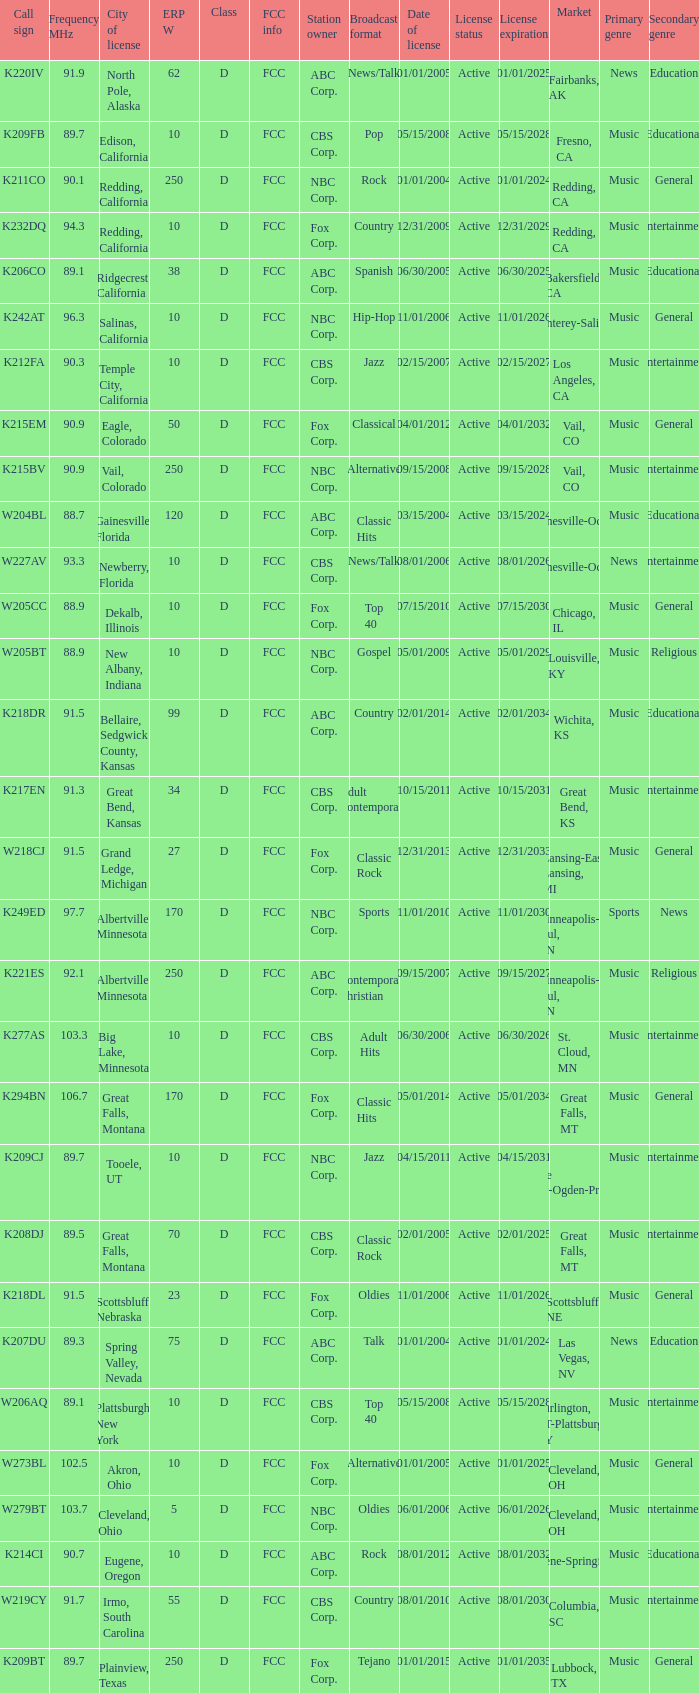Could you help me parse every detail presented in this table? {'header': ['Call sign', 'Frequency MHz', 'City of license', 'ERP W', 'Class', 'FCC info', 'Station owner', 'Broadcast format', 'Date of license', 'License status', 'License expiration', 'Market', 'Primary genre', 'Secondary genre'], 'rows': [['K220IV', '91.9', 'North Pole, Alaska', '62', 'D', 'FCC', 'ABC Corp.', 'News/Talk', '01/01/2005', 'Active', '01/01/2025', 'Fairbanks, AK', 'News', 'Education'], ['K209FB', '89.7', 'Edison, California', '10', 'D', 'FCC', 'CBS Corp.', 'Pop', '05/15/2008', 'Active', '05/15/2028', 'Fresno, CA', 'Music', 'Educational'], ['K211CO', '90.1', 'Redding, California', '250', 'D', 'FCC', 'NBC Corp.', 'Rock', '01/01/2004', 'Active', '01/01/2024', 'Redding, CA', 'Music', 'General'], ['K232DQ', '94.3', 'Redding, California', '10', 'D', 'FCC', 'Fox Corp.', 'Country', '12/31/2009', 'Active', '12/31/2029', 'Redding, CA', 'Music', 'Entertainment'], ['K206CO', '89.1', 'Ridgecrest, California', '38', 'D', 'FCC', 'ABC Corp.', 'Spanish', '06/30/2005', 'Active', '06/30/2025', 'Bakersfield, CA', 'Music', 'Educational'], ['K242AT', '96.3', 'Salinas, California', '10', 'D', 'FCC', 'NBC Corp.', 'Hip-Hop', '11/01/2006', 'Active', '11/01/2026', 'Monterey-Salinas, CA', 'Music', 'General'], ['K212FA', '90.3', 'Temple City, California', '10', 'D', 'FCC', 'CBS Corp.', 'Jazz', '02/15/2007', 'Active', '02/15/2027', 'Los Angeles, CA', 'Music', 'Entertainment'], ['K215EM', '90.9', 'Eagle, Colorado', '50', 'D', 'FCC', 'Fox Corp.', 'Classical', '04/01/2012', 'Active', '04/01/2032', 'Vail, CO', 'Music', 'General'], ['K215BV', '90.9', 'Vail, Colorado', '250', 'D', 'FCC', 'NBC Corp.', 'Alternative', '09/15/2008', 'Active', '09/15/2028', 'Vail, CO', 'Music', 'Entertainment'], ['W204BL', '88.7', 'Gainesville, Florida', '120', 'D', 'FCC', 'ABC Corp.', 'Classic Hits', '03/15/2004', 'Active', '03/15/2024', 'Gainesville-Ocala, FL', 'Music', 'Educational'], ['W227AV', '93.3', 'Newberry, Florida', '10', 'D', 'FCC', 'CBS Corp.', 'News/Talk', '08/01/2006', 'Active', '08/01/2026', 'Gainesville-Ocala, FL', 'News', 'Entertainment'], ['W205CC', '88.9', 'Dekalb, Illinois', '10', 'D', 'FCC', 'Fox Corp.', 'Top 40', '07/15/2010', 'Active', '07/15/2030', 'Chicago, IL', 'Music', 'General'], ['W205BT', '88.9', 'New Albany, Indiana', '10', 'D', 'FCC', 'NBC Corp.', 'Gospel', '05/01/2009', 'Active', '05/01/2029', 'Louisville, KY', 'Music', 'Religious'], ['K218DR', '91.5', 'Bellaire, Sedgwick County, Kansas', '99', 'D', 'FCC', 'ABC Corp.', 'Country', '02/01/2014', 'Active', '02/01/2034', 'Wichita, KS', 'Music', 'Educational'], ['K217EN', '91.3', 'Great Bend, Kansas', '34', 'D', 'FCC', 'CBS Corp.', 'Adult Contemporary', '10/15/2011', 'Active', '10/15/2031', 'Great Bend, KS', 'Music', 'Entertainment'], ['W218CJ', '91.5', 'Grand Ledge, Michigan', '27', 'D', 'FCC', 'Fox Corp.', 'Classic Rock', '12/31/2013', 'Active', '12/31/2033', 'Lansing-East Lansing, MI', 'Music', 'General'], ['K249ED', '97.7', 'Albertville, Minnesota', '170', 'D', 'FCC', 'NBC Corp.', 'Sports', '11/01/2010', 'Active', '11/01/2030', 'Minneapolis-St. Paul, MN', 'Sports', 'News'], ['K221ES', '92.1', 'Albertville, Minnesota', '250', 'D', 'FCC', 'ABC Corp.', 'Contemporary Christian', '09/15/2007', 'Active', '09/15/2027', 'Minneapolis-St. Paul, MN', 'Music', 'Religious'], ['K277AS', '103.3', 'Big Lake, Minnesota', '10', 'D', 'FCC', 'CBS Corp.', 'Adult Hits', '06/30/2006', 'Active', '06/30/2026', 'St. Cloud, MN', 'Music', 'Entertainment'], ['K294BN', '106.7', 'Great Falls, Montana', '170', 'D', 'FCC', 'Fox Corp.', 'Classic Hits', '05/01/2014', 'Active', '05/01/2034', 'Great Falls, MT', 'Music', 'General'], ['K209CJ', '89.7', 'Tooele, UT', '10', 'D', 'FCC', 'NBC Corp.', 'Jazz', '04/15/2011', 'Active', '04/15/2031', 'Salt Lake City-Ogden-Provo, UT', 'Music', 'Entertainment'], ['K208DJ', '89.5', 'Great Falls, Montana', '70', 'D', 'FCC', 'CBS Corp.', 'Classic Rock', '02/01/2005', 'Active', '02/01/2025', 'Great Falls, MT', 'Music', 'Entertainment'], ['K218DL', '91.5', 'Scottsbluff, Nebraska', '23', 'D', 'FCC', 'Fox Corp.', 'Oldies', '11/01/2006', 'Active', '11/01/2026', 'Scottsbluff, NE', 'Music', 'General'], ['K207DU', '89.3', 'Spring Valley, Nevada', '75', 'D', 'FCC', 'ABC Corp.', 'Talk', '01/01/2004', 'Active', '01/01/2024', 'Las Vegas, NV', 'News', 'Education'], ['W206AQ', '89.1', 'Plattsburgh, New York', '10', 'D', 'FCC', 'CBS Corp.', 'Top 40', '05/15/2008', 'Active', '05/15/2028', 'Burlington, VT-Plattsburgh, NY', 'Music', 'Entertainment'], ['W273BL', '102.5', 'Akron, Ohio', '10', 'D', 'FCC', 'Fox Corp.', 'Alternative', '01/01/2005', 'Active', '01/01/2025', 'Cleveland, OH', 'Music', 'General'], ['W279BT', '103.7', 'Cleveland, Ohio', '5', 'D', 'FCC', 'NBC Corp.', 'Oldies', '06/01/2006', 'Active', '06/01/2026', 'Cleveland, OH', 'Music', 'Entertainment'], ['K214CI', '90.7', 'Eugene, Oregon', '10', 'D', 'FCC', 'ABC Corp.', 'Rock', '08/01/2012', 'Active', '08/01/2032', 'Eugene-Springfield, OR', 'Music', 'Educational'], ['W219CY', '91.7', 'Irmo, South Carolina', '55', 'D', 'FCC', 'CBS Corp.', 'Country', '08/01/2010', 'Active', '08/01/2030', 'Columbia, SC', 'Music', 'Entertainment'], ['K209BT', '89.7', 'Plainview, Texas', '250', 'D', 'FCC', 'Fox Corp.', 'Tejano', '01/01/2015', 'Active', '01/01/2035', 'Lubbock, TX', 'Music', 'General']]} What is the call sign of the translator with an ERP W greater than 38 and a city license from Great Falls, Montana? K294BN, K208DJ. 